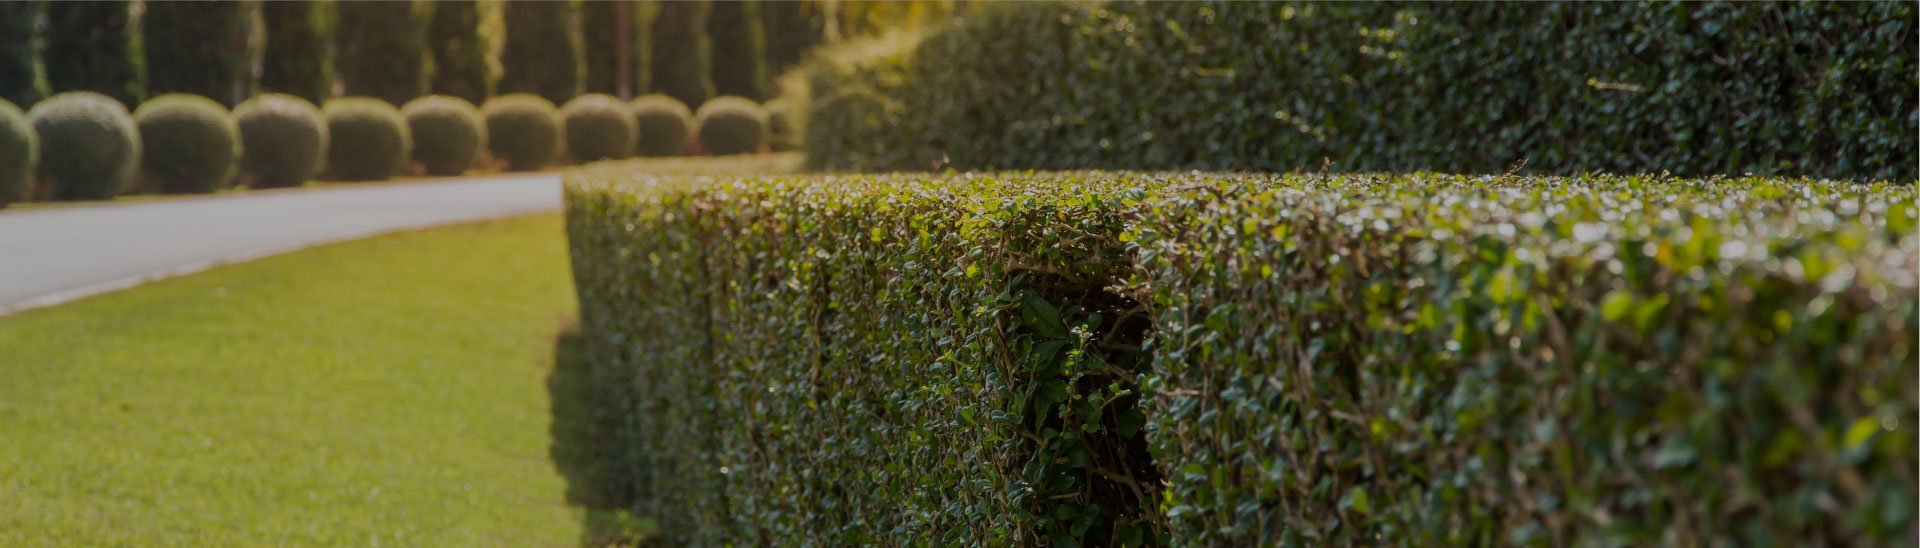How does the condition of the hedge and topiary bushes contribute to the overall impression of the garden's maintenance? The meticulous condition of the hedge and topiary bushes significantly enhances the garden's aesthetic. The hedges, with their impeccably straight tops and smoothly vertical sides, reflect a routine and careful trimming process. Similarly, the spherical topiary bushes, uniform in shape and size, underscore a high level of precision in their upkeep. Together, these elements not only suggest but distinctly showcase a garden maintained with exceptional attention to detail, likely under the care of skilled gardeners. This level of care contributes to creating a visually appealing and orderly outdoor space that welcomes visitors with its manicured appearance. 